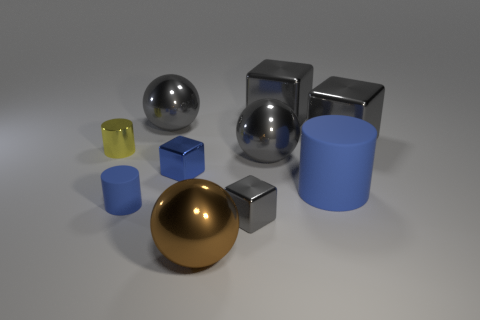How many gray cubes must be subtracted to get 1 gray cubes? 2 Subtract all gray metal balls. How many balls are left? 1 Subtract all blue cubes. How many cubes are left? 3 Subtract 2 spheres. How many spheres are left? 1 Subtract all cylinders. How many objects are left? 7 Subtract all gray blocks. How many blue cylinders are left? 2 Subtract all gray metallic things. Subtract all tiny gray metal objects. How many objects are left? 4 Add 4 big brown metallic balls. How many big brown metallic balls are left? 5 Add 5 gray balls. How many gray balls exist? 7 Subtract 0 green blocks. How many objects are left? 10 